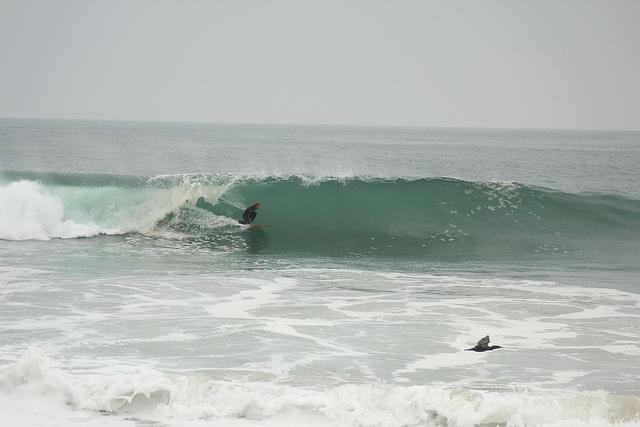How many scissors are in blue color?
Give a very brief answer. 0. 